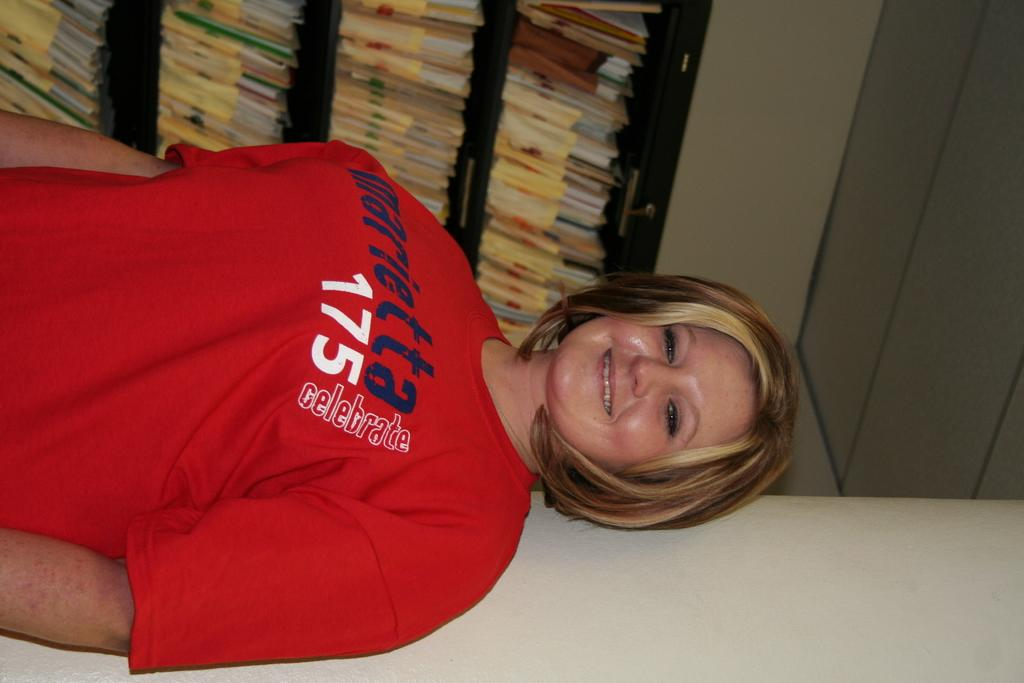<image>
Offer a succinct explanation of the picture presented. A woman wearing a Marietta 175 t-shirt smiles in front of a bookshelf. 